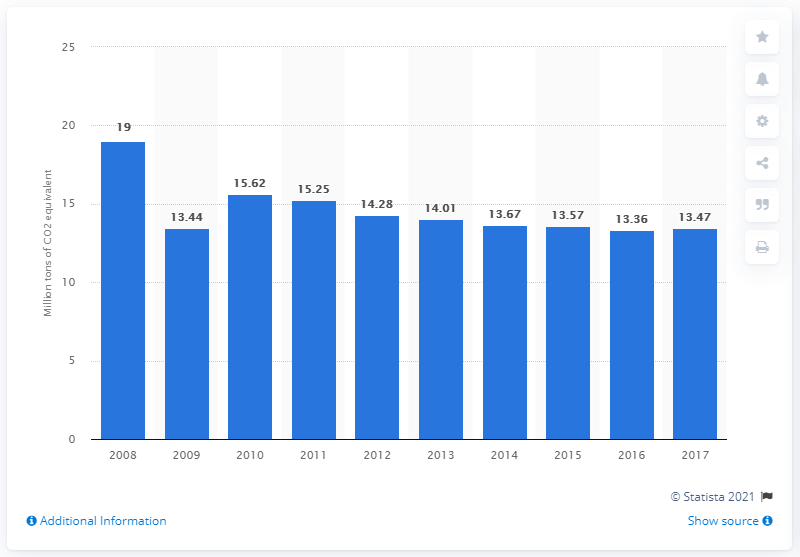What does the graph show about the trend in CO2 emissions in Belgium from 2008 to 2017? The graph displays a general decline in CO2 emissions in Belgium from 2008, where it peaked at 19 million tons of CO2 equivalent, to 2017, where it reduced to 13.47 million tons. This suggests a successful implementation of environmental policies and a shift towards cleaner energy sources over the decade. 